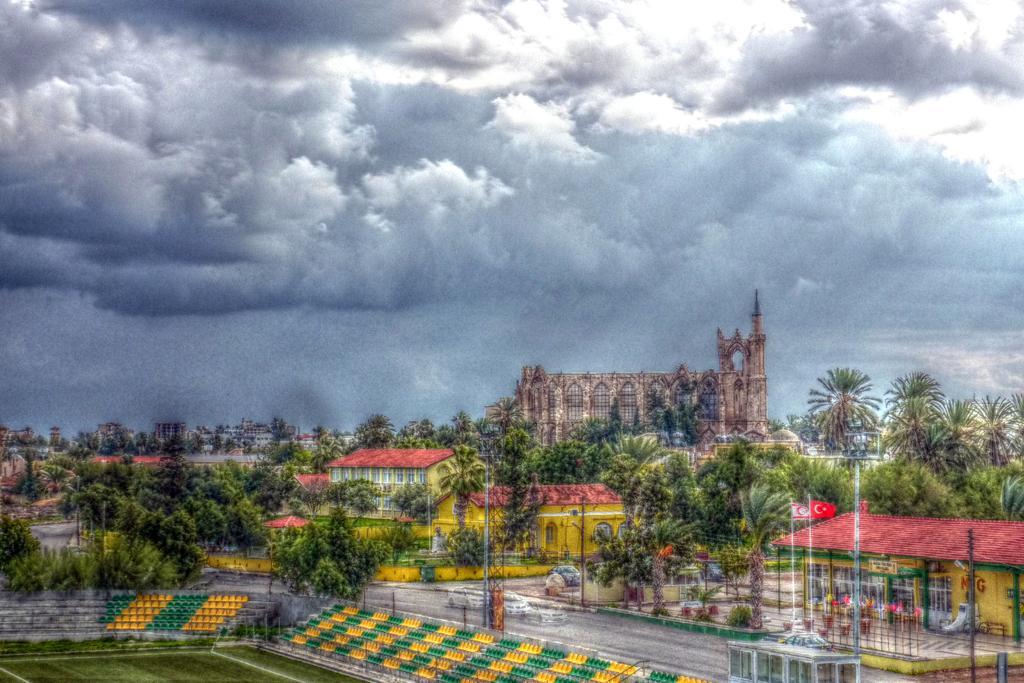Can you describe this image briefly? In this image we can see houses, buildings, trees, poles, flags, vehicles, road, chairs, grass, plants, and few objects. In the background there is sky with clouds. 